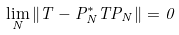Convert formula to latex. <formula><loc_0><loc_0><loc_500><loc_500>\lim _ { N } \| T - P _ { N } ^ { * } T P _ { N } \| = 0</formula> 